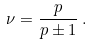Convert formula to latex. <formula><loc_0><loc_0><loc_500><loc_500>\nu = \frac { p } { p \pm 1 } \, .</formula> 